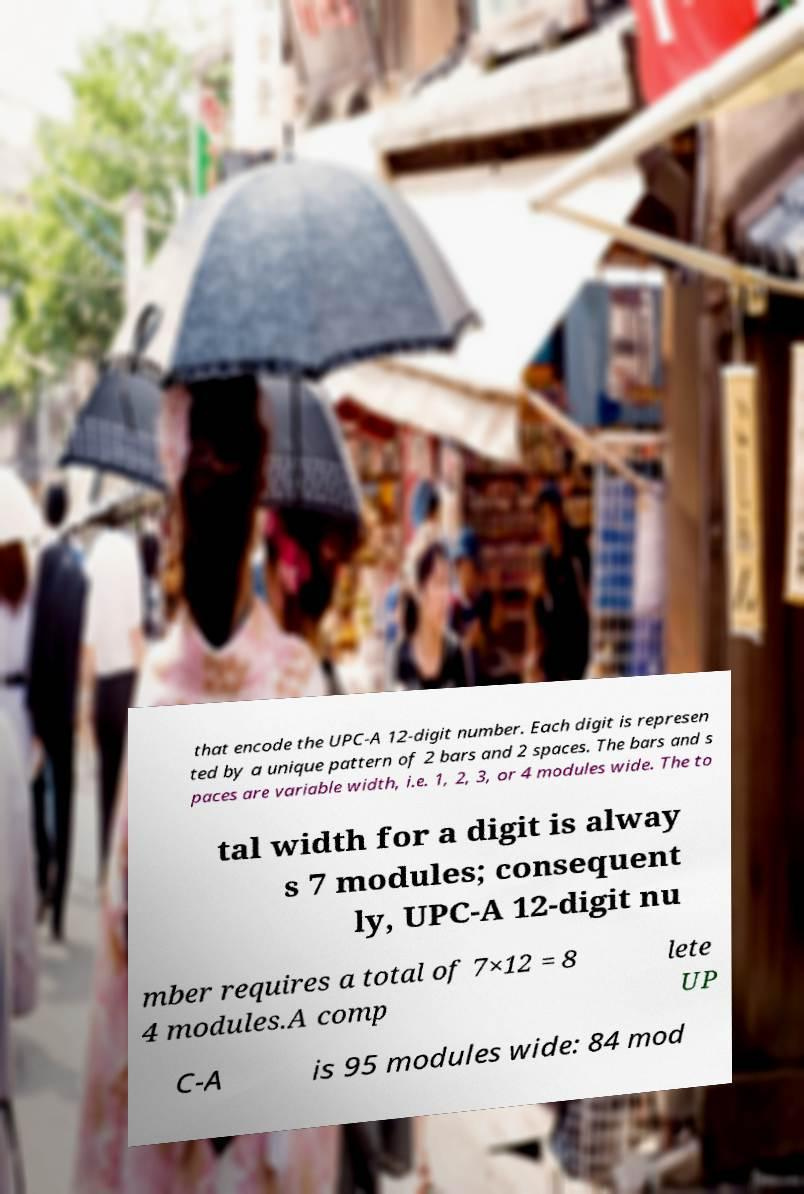Please identify and transcribe the text found in this image. that encode the UPC-A 12-digit number. Each digit is represen ted by a unique pattern of 2 bars and 2 spaces. The bars and s paces are variable width, i.e. 1, 2, 3, or 4 modules wide. The to tal width for a digit is alway s 7 modules; consequent ly, UPC-A 12-digit nu mber requires a total of 7×12 = 8 4 modules.A comp lete UP C-A is 95 modules wide: 84 mod 